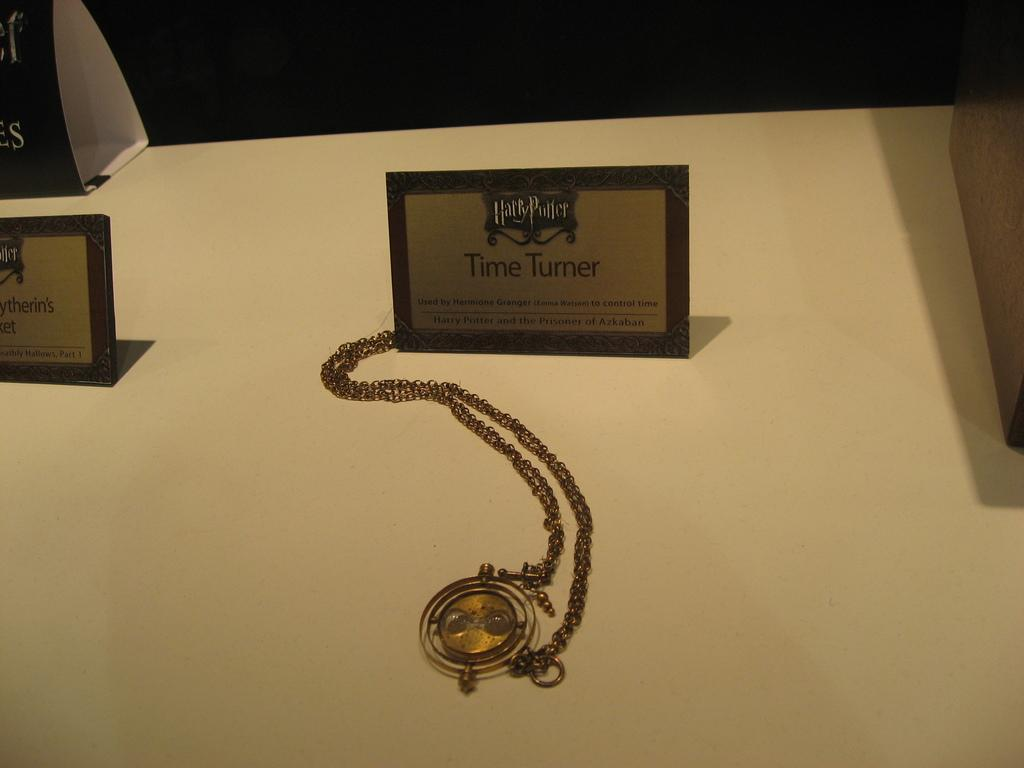<image>
Give a short and clear explanation of the subsequent image. A necklace sits in front of a placard for Harry Potter. 